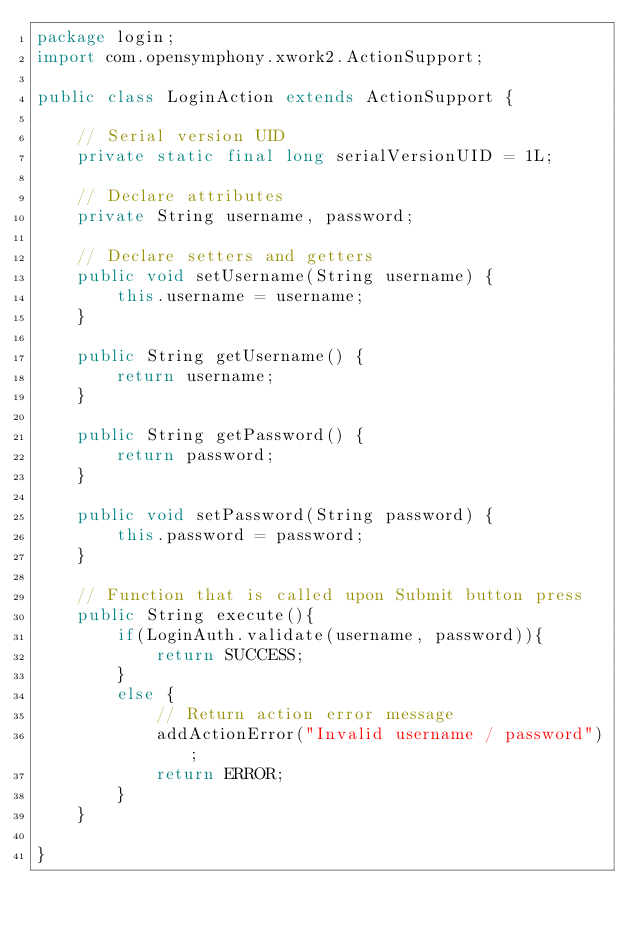<code> <loc_0><loc_0><loc_500><loc_500><_Java_>package login;
import com.opensymphony.xwork2.ActionSupport;

public class LoginAction extends ActionSupport {

	// Serial version UID
	private static final long serialVersionUID = 1L;
	
	// Declare attributes
	private String username, password;
	
	// Declare setters and getters
	public void setUsername(String username) {  
	    this.username = username;  
	}
	
	public String getUsername() {
		return username;
	}
	  
	public String getPassword() {  
	    return password;  
	}  
	  
	public void setPassword(String password) {  
	    this.password = password;  
	}
	
	// Function that is called upon Submit button press
	public String execute(){  
	    if(LoginAuth.validate(username, password)){  
	        return SUCCESS;  
	    }  
	    else {
	    	// Return action error message
	    	addActionError("Invalid username / password");
	        return ERROR;  
	    }  
	}  
	
}
</code> 